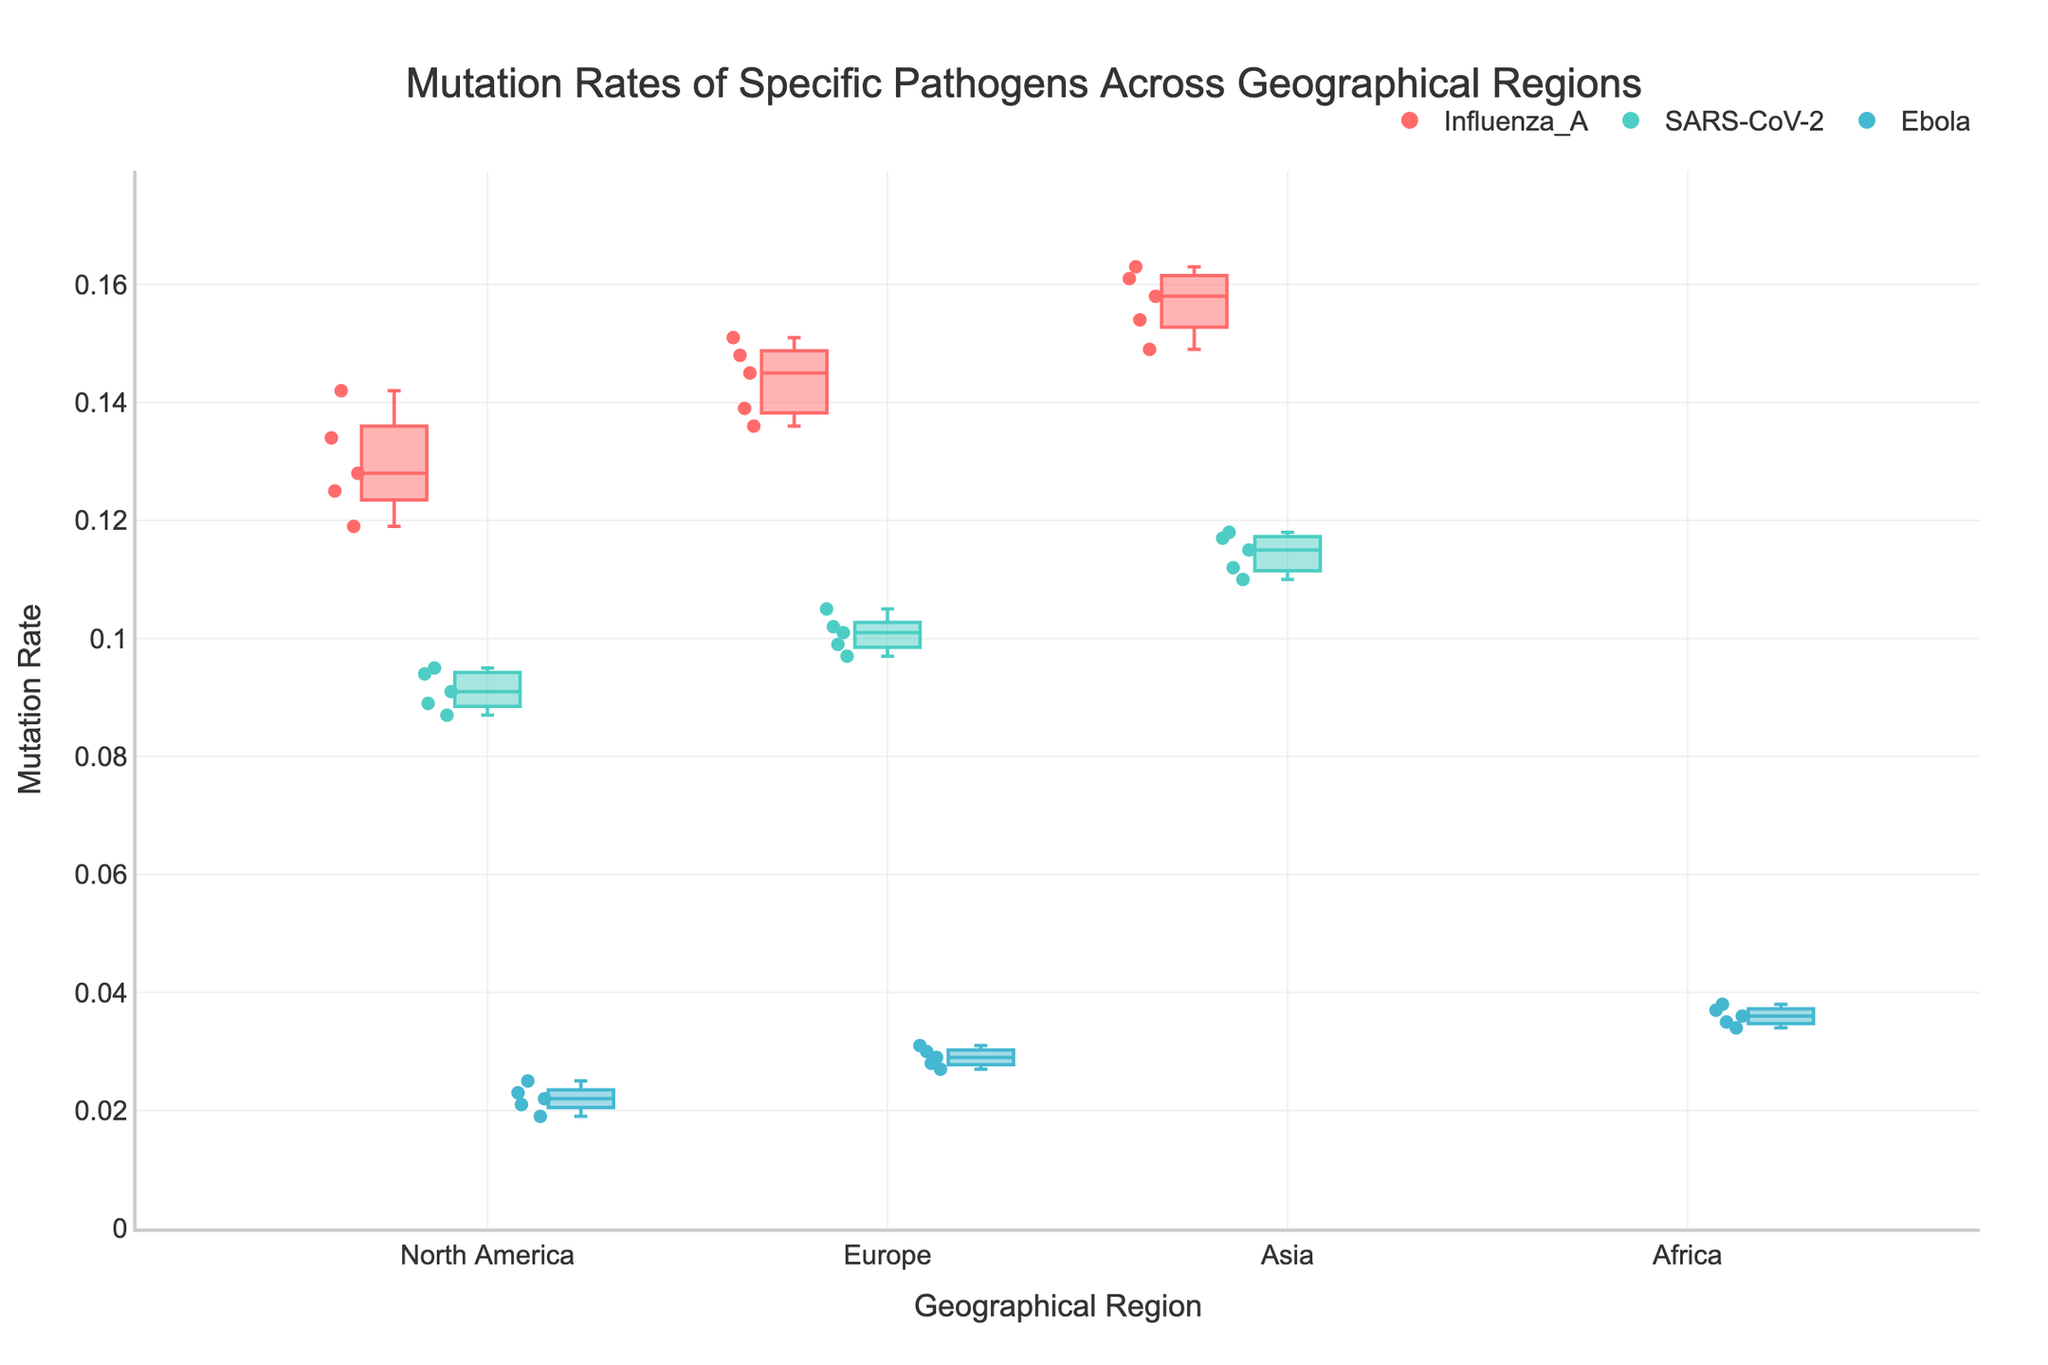What's the title of the figure? The title of the figure is displayed at the top, centered. It is a descriptive textual element summarizing the content of the plot.
Answer: Mutation Rates of Specific Pathogens Across Geographical Regions What are the y-axis units? The y-axis represents the mutation rates, which are probably in a fraction or percentage format. This is usually determined by looking at the y-axis labels.
Answer: Mutation Rate Which pathogen has the highest overall mutation rate? Look at the highest data points for each pathogen. The pathogen with the maximum value among these points has the highest overall mutation rate.
Answer: Influenza_A How many geographical regions are represented in the plot? Count the unique labels along the x-axis indicating geographical regions.
Answer: 3 What is the mutation rate range for Influenza A in Europe? Look for the box plot of Influenza A in Europe and identify the minimum and maximum whisker values, which represent the range.
Answer: 0.136 to 0.151 Compare the median mutation rates of SARS-CoV-2 in North America and Asia. Which is higher? Identify the median line within the box for SARS-CoV-2 in both North America and Asia. The position of these lines clearly indicates the comparison.
Answer: Asia Which geographical region shows the highest variability in mutation rates for Ebola? Evaluate the spread of the data points and the range of the box plot whiskers for Ebola in each region. The region with the largest spread indicates the highest variability.
Answer: Africa What is the interquartile range (IQR) for SARS-CoV-2 in Europe? The IQR is the difference between the third quartile (Q3) and the first quartile (Q1) values in the box of SARS-CoV-2 in Europe. Identify these from the box plot and subtract Q1 from Q3.
Answer: 0.099 to 0.102 How do the mutation rates of Ebola in North America compare to those in Europe? Look at the boxes and scatter points for both regions and compare their spread, median, and overall range. Determine if one set is generally higher or lower than the other.
Answer: Europe has higher rates Which pathogen and geographical region combination has the lowest median mutation rate? Identify the median lines within the boxes for each combination. The combination with the lowest median line represents the lowest median mutation rate.
Answer: Ebola in North America 